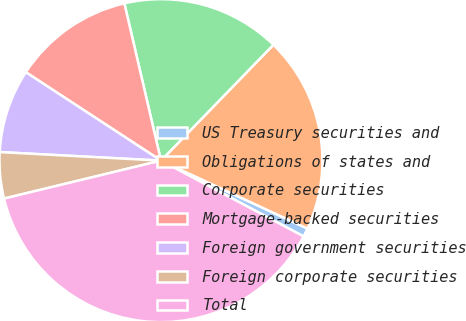Convert chart. <chart><loc_0><loc_0><loc_500><loc_500><pie_chart><fcel>US Treasury securities and<fcel>Obligations of states and<fcel>Corporate securities<fcel>Mortgage-backed securities<fcel>Foreign government securities<fcel>Foreign corporate securities<fcel>Total<nl><fcel>0.86%<fcel>19.65%<fcel>15.9%<fcel>12.14%<fcel>8.38%<fcel>4.62%<fcel>38.45%<nl></chart> 